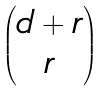<formula> <loc_0><loc_0><loc_500><loc_500>\begin{pmatrix} d + r \\ r \end{pmatrix}</formula> 